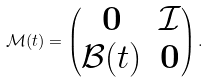Convert formula to latex. <formula><loc_0><loc_0><loc_500><loc_500>\mathcal { M } ( t ) = \begin{pmatrix} \mathbf 0 & \mathcal { I } \\ \mathcal { B } ( t ) & \mathbf 0 \end{pmatrix} .</formula> 